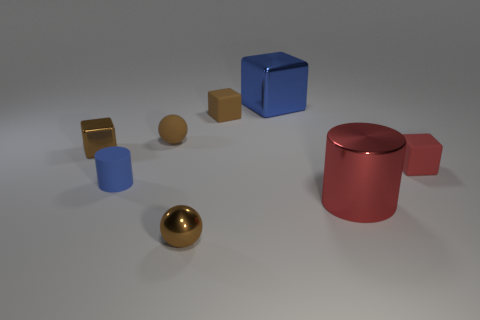Subtract all yellow cylinders. How many brown blocks are left? 2 Subtract all big cubes. How many cubes are left? 3 Add 1 tiny yellow rubber things. How many objects exist? 9 Subtract 1 cubes. How many cubes are left? 3 Subtract all blue blocks. How many blocks are left? 3 Subtract all cylinders. How many objects are left? 6 Subtract all small red rubber objects. Subtract all red cubes. How many objects are left? 6 Add 4 big metallic blocks. How many big metallic blocks are left? 5 Add 3 large cylinders. How many large cylinders exist? 4 Subtract 0 yellow spheres. How many objects are left? 8 